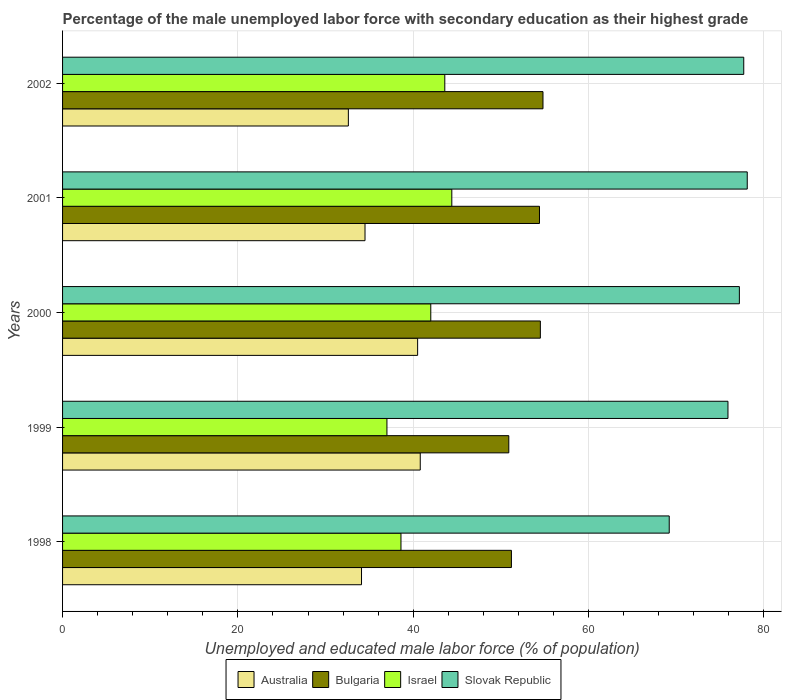How many different coloured bars are there?
Ensure brevity in your answer.  4. How many groups of bars are there?
Provide a succinct answer. 5. Are the number of bars per tick equal to the number of legend labels?
Keep it short and to the point. Yes. How many bars are there on the 2nd tick from the bottom?
Your response must be concise. 4. Across all years, what is the maximum percentage of the unemployed male labor force with secondary education in Slovak Republic?
Provide a succinct answer. 78.1. Across all years, what is the minimum percentage of the unemployed male labor force with secondary education in Slovak Republic?
Make the answer very short. 69.2. In which year was the percentage of the unemployed male labor force with secondary education in Slovak Republic maximum?
Your response must be concise. 2001. In which year was the percentage of the unemployed male labor force with secondary education in Slovak Republic minimum?
Offer a terse response. 1998. What is the total percentage of the unemployed male labor force with secondary education in Australia in the graph?
Offer a very short reply. 182.5. What is the difference between the percentage of the unemployed male labor force with secondary education in Australia in 2000 and that in 2002?
Offer a very short reply. 7.9. What is the difference between the percentage of the unemployed male labor force with secondary education in Bulgaria in 1999 and the percentage of the unemployed male labor force with secondary education in Slovak Republic in 2002?
Offer a terse response. -26.8. What is the average percentage of the unemployed male labor force with secondary education in Slovak Republic per year?
Provide a succinct answer. 75.62. In the year 2001, what is the difference between the percentage of the unemployed male labor force with secondary education in Australia and percentage of the unemployed male labor force with secondary education in Slovak Republic?
Your answer should be very brief. -43.6. In how many years, is the percentage of the unemployed male labor force with secondary education in Slovak Republic greater than 44 %?
Keep it short and to the point. 5. What is the ratio of the percentage of the unemployed male labor force with secondary education in Slovak Republic in 1999 to that in 2001?
Your response must be concise. 0.97. What is the difference between the highest and the second highest percentage of the unemployed male labor force with secondary education in Australia?
Offer a very short reply. 0.3. What is the difference between the highest and the lowest percentage of the unemployed male labor force with secondary education in Australia?
Provide a short and direct response. 8.2. In how many years, is the percentage of the unemployed male labor force with secondary education in Slovak Republic greater than the average percentage of the unemployed male labor force with secondary education in Slovak Republic taken over all years?
Ensure brevity in your answer.  4. Is it the case that in every year, the sum of the percentage of the unemployed male labor force with secondary education in Bulgaria and percentage of the unemployed male labor force with secondary education in Slovak Republic is greater than the sum of percentage of the unemployed male labor force with secondary education in Australia and percentage of the unemployed male labor force with secondary education in Israel?
Your answer should be compact. No. What does the 4th bar from the bottom in 2001 represents?
Your response must be concise. Slovak Republic. Is it the case that in every year, the sum of the percentage of the unemployed male labor force with secondary education in Australia and percentage of the unemployed male labor force with secondary education in Slovak Republic is greater than the percentage of the unemployed male labor force with secondary education in Bulgaria?
Make the answer very short. Yes. How many bars are there?
Offer a very short reply. 20. How many legend labels are there?
Offer a terse response. 4. What is the title of the graph?
Make the answer very short. Percentage of the male unemployed labor force with secondary education as their highest grade. Does "Finland" appear as one of the legend labels in the graph?
Offer a terse response. No. What is the label or title of the X-axis?
Ensure brevity in your answer.  Unemployed and educated male labor force (% of population). What is the Unemployed and educated male labor force (% of population) of Australia in 1998?
Offer a terse response. 34.1. What is the Unemployed and educated male labor force (% of population) in Bulgaria in 1998?
Give a very brief answer. 51.2. What is the Unemployed and educated male labor force (% of population) of Israel in 1998?
Provide a short and direct response. 38.6. What is the Unemployed and educated male labor force (% of population) in Slovak Republic in 1998?
Give a very brief answer. 69.2. What is the Unemployed and educated male labor force (% of population) in Australia in 1999?
Provide a succinct answer. 40.8. What is the Unemployed and educated male labor force (% of population) of Bulgaria in 1999?
Ensure brevity in your answer.  50.9. What is the Unemployed and educated male labor force (% of population) in Israel in 1999?
Offer a terse response. 37. What is the Unemployed and educated male labor force (% of population) in Slovak Republic in 1999?
Give a very brief answer. 75.9. What is the Unemployed and educated male labor force (% of population) in Australia in 2000?
Provide a short and direct response. 40.5. What is the Unemployed and educated male labor force (% of population) of Bulgaria in 2000?
Provide a succinct answer. 54.5. What is the Unemployed and educated male labor force (% of population) of Israel in 2000?
Keep it short and to the point. 42. What is the Unemployed and educated male labor force (% of population) of Slovak Republic in 2000?
Make the answer very short. 77.2. What is the Unemployed and educated male labor force (% of population) of Australia in 2001?
Provide a short and direct response. 34.5. What is the Unemployed and educated male labor force (% of population) in Bulgaria in 2001?
Your response must be concise. 54.4. What is the Unemployed and educated male labor force (% of population) of Israel in 2001?
Provide a short and direct response. 44.4. What is the Unemployed and educated male labor force (% of population) in Slovak Republic in 2001?
Your answer should be compact. 78.1. What is the Unemployed and educated male labor force (% of population) in Australia in 2002?
Your answer should be very brief. 32.6. What is the Unemployed and educated male labor force (% of population) of Bulgaria in 2002?
Your response must be concise. 54.8. What is the Unemployed and educated male labor force (% of population) of Israel in 2002?
Provide a succinct answer. 43.6. What is the Unemployed and educated male labor force (% of population) of Slovak Republic in 2002?
Ensure brevity in your answer.  77.7. Across all years, what is the maximum Unemployed and educated male labor force (% of population) in Australia?
Make the answer very short. 40.8. Across all years, what is the maximum Unemployed and educated male labor force (% of population) in Bulgaria?
Keep it short and to the point. 54.8. Across all years, what is the maximum Unemployed and educated male labor force (% of population) in Israel?
Your answer should be very brief. 44.4. Across all years, what is the maximum Unemployed and educated male labor force (% of population) of Slovak Republic?
Make the answer very short. 78.1. Across all years, what is the minimum Unemployed and educated male labor force (% of population) of Australia?
Provide a short and direct response. 32.6. Across all years, what is the minimum Unemployed and educated male labor force (% of population) in Bulgaria?
Offer a very short reply. 50.9. Across all years, what is the minimum Unemployed and educated male labor force (% of population) of Israel?
Provide a short and direct response. 37. Across all years, what is the minimum Unemployed and educated male labor force (% of population) of Slovak Republic?
Ensure brevity in your answer.  69.2. What is the total Unemployed and educated male labor force (% of population) in Australia in the graph?
Your answer should be very brief. 182.5. What is the total Unemployed and educated male labor force (% of population) in Bulgaria in the graph?
Ensure brevity in your answer.  265.8. What is the total Unemployed and educated male labor force (% of population) of Israel in the graph?
Make the answer very short. 205.6. What is the total Unemployed and educated male labor force (% of population) of Slovak Republic in the graph?
Make the answer very short. 378.1. What is the difference between the Unemployed and educated male labor force (% of population) of Israel in 1998 and that in 1999?
Provide a short and direct response. 1.6. What is the difference between the Unemployed and educated male labor force (% of population) of Israel in 1998 and that in 2000?
Your answer should be very brief. -3.4. What is the difference between the Unemployed and educated male labor force (% of population) in Australia in 1998 and that in 2001?
Your answer should be very brief. -0.4. What is the difference between the Unemployed and educated male labor force (% of population) of Israel in 1998 and that in 2001?
Give a very brief answer. -5.8. What is the difference between the Unemployed and educated male labor force (% of population) in Australia in 1998 and that in 2002?
Provide a short and direct response. 1.5. What is the difference between the Unemployed and educated male labor force (% of population) in Bulgaria in 1998 and that in 2002?
Your answer should be compact. -3.6. What is the difference between the Unemployed and educated male labor force (% of population) in Israel in 1998 and that in 2002?
Your answer should be very brief. -5. What is the difference between the Unemployed and educated male labor force (% of population) of Slovak Republic in 1998 and that in 2002?
Your response must be concise. -8.5. What is the difference between the Unemployed and educated male labor force (% of population) in Australia in 1999 and that in 2000?
Offer a very short reply. 0.3. What is the difference between the Unemployed and educated male labor force (% of population) of Bulgaria in 1999 and that in 2000?
Provide a short and direct response. -3.6. What is the difference between the Unemployed and educated male labor force (% of population) of Australia in 1999 and that in 2001?
Ensure brevity in your answer.  6.3. What is the difference between the Unemployed and educated male labor force (% of population) in Israel in 1999 and that in 2001?
Ensure brevity in your answer.  -7.4. What is the difference between the Unemployed and educated male labor force (% of population) in Slovak Republic in 1999 and that in 2001?
Your answer should be very brief. -2.2. What is the difference between the Unemployed and educated male labor force (% of population) in Bulgaria in 1999 and that in 2002?
Offer a very short reply. -3.9. What is the difference between the Unemployed and educated male labor force (% of population) in Slovak Republic in 2000 and that in 2001?
Provide a short and direct response. -0.9. What is the difference between the Unemployed and educated male labor force (% of population) of Australia in 2000 and that in 2002?
Offer a very short reply. 7.9. What is the difference between the Unemployed and educated male labor force (% of population) of Bulgaria in 2000 and that in 2002?
Offer a terse response. -0.3. What is the difference between the Unemployed and educated male labor force (% of population) of Slovak Republic in 2000 and that in 2002?
Keep it short and to the point. -0.5. What is the difference between the Unemployed and educated male labor force (% of population) of Bulgaria in 2001 and that in 2002?
Ensure brevity in your answer.  -0.4. What is the difference between the Unemployed and educated male labor force (% of population) of Israel in 2001 and that in 2002?
Ensure brevity in your answer.  0.8. What is the difference between the Unemployed and educated male labor force (% of population) in Slovak Republic in 2001 and that in 2002?
Provide a succinct answer. 0.4. What is the difference between the Unemployed and educated male labor force (% of population) in Australia in 1998 and the Unemployed and educated male labor force (% of population) in Bulgaria in 1999?
Make the answer very short. -16.8. What is the difference between the Unemployed and educated male labor force (% of population) in Australia in 1998 and the Unemployed and educated male labor force (% of population) in Slovak Republic in 1999?
Give a very brief answer. -41.8. What is the difference between the Unemployed and educated male labor force (% of population) of Bulgaria in 1998 and the Unemployed and educated male labor force (% of population) of Slovak Republic in 1999?
Provide a short and direct response. -24.7. What is the difference between the Unemployed and educated male labor force (% of population) in Israel in 1998 and the Unemployed and educated male labor force (% of population) in Slovak Republic in 1999?
Keep it short and to the point. -37.3. What is the difference between the Unemployed and educated male labor force (% of population) of Australia in 1998 and the Unemployed and educated male labor force (% of population) of Bulgaria in 2000?
Provide a succinct answer. -20.4. What is the difference between the Unemployed and educated male labor force (% of population) in Australia in 1998 and the Unemployed and educated male labor force (% of population) in Slovak Republic in 2000?
Your response must be concise. -43.1. What is the difference between the Unemployed and educated male labor force (% of population) of Bulgaria in 1998 and the Unemployed and educated male labor force (% of population) of Slovak Republic in 2000?
Your response must be concise. -26. What is the difference between the Unemployed and educated male labor force (% of population) of Israel in 1998 and the Unemployed and educated male labor force (% of population) of Slovak Republic in 2000?
Your answer should be very brief. -38.6. What is the difference between the Unemployed and educated male labor force (% of population) of Australia in 1998 and the Unemployed and educated male labor force (% of population) of Bulgaria in 2001?
Make the answer very short. -20.3. What is the difference between the Unemployed and educated male labor force (% of population) in Australia in 1998 and the Unemployed and educated male labor force (% of population) in Slovak Republic in 2001?
Provide a short and direct response. -44. What is the difference between the Unemployed and educated male labor force (% of population) in Bulgaria in 1998 and the Unemployed and educated male labor force (% of population) in Slovak Republic in 2001?
Your answer should be compact. -26.9. What is the difference between the Unemployed and educated male labor force (% of population) in Israel in 1998 and the Unemployed and educated male labor force (% of population) in Slovak Republic in 2001?
Give a very brief answer. -39.5. What is the difference between the Unemployed and educated male labor force (% of population) of Australia in 1998 and the Unemployed and educated male labor force (% of population) of Bulgaria in 2002?
Ensure brevity in your answer.  -20.7. What is the difference between the Unemployed and educated male labor force (% of population) in Australia in 1998 and the Unemployed and educated male labor force (% of population) in Israel in 2002?
Give a very brief answer. -9.5. What is the difference between the Unemployed and educated male labor force (% of population) in Australia in 1998 and the Unemployed and educated male labor force (% of population) in Slovak Republic in 2002?
Your response must be concise. -43.6. What is the difference between the Unemployed and educated male labor force (% of population) of Bulgaria in 1998 and the Unemployed and educated male labor force (% of population) of Slovak Republic in 2002?
Keep it short and to the point. -26.5. What is the difference between the Unemployed and educated male labor force (% of population) in Israel in 1998 and the Unemployed and educated male labor force (% of population) in Slovak Republic in 2002?
Provide a succinct answer. -39.1. What is the difference between the Unemployed and educated male labor force (% of population) in Australia in 1999 and the Unemployed and educated male labor force (% of population) in Bulgaria in 2000?
Give a very brief answer. -13.7. What is the difference between the Unemployed and educated male labor force (% of population) of Australia in 1999 and the Unemployed and educated male labor force (% of population) of Slovak Republic in 2000?
Provide a short and direct response. -36.4. What is the difference between the Unemployed and educated male labor force (% of population) of Bulgaria in 1999 and the Unemployed and educated male labor force (% of population) of Slovak Republic in 2000?
Ensure brevity in your answer.  -26.3. What is the difference between the Unemployed and educated male labor force (% of population) of Israel in 1999 and the Unemployed and educated male labor force (% of population) of Slovak Republic in 2000?
Offer a very short reply. -40.2. What is the difference between the Unemployed and educated male labor force (% of population) of Australia in 1999 and the Unemployed and educated male labor force (% of population) of Israel in 2001?
Ensure brevity in your answer.  -3.6. What is the difference between the Unemployed and educated male labor force (% of population) in Australia in 1999 and the Unemployed and educated male labor force (% of population) in Slovak Republic in 2001?
Give a very brief answer. -37.3. What is the difference between the Unemployed and educated male labor force (% of population) in Bulgaria in 1999 and the Unemployed and educated male labor force (% of population) in Israel in 2001?
Provide a short and direct response. 6.5. What is the difference between the Unemployed and educated male labor force (% of population) of Bulgaria in 1999 and the Unemployed and educated male labor force (% of population) of Slovak Republic in 2001?
Provide a short and direct response. -27.2. What is the difference between the Unemployed and educated male labor force (% of population) in Israel in 1999 and the Unemployed and educated male labor force (% of population) in Slovak Republic in 2001?
Provide a short and direct response. -41.1. What is the difference between the Unemployed and educated male labor force (% of population) in Australia in 1999 and the Unemployed and educated male labor force (% of population) in Slovak Republic in 2002?
Your answer should be very brief. -36.9. What is the difference between the Unemployed and educated male labor force (% of population) in Bulgaria in 1999 and the Unemployed and educated male labor force (% of population) in Israel in 2002?
Offer a terse response. 7.3. What is the difference between the Unemployed and educated male labor force (% of population) of Bulgaria in 1999 and the Unemployed and educated male labor force (% of population) of Slovak Republic in 2002?
Offer a terse response. -26.8. What is the difference between the Unemployed and educated male labor force (% of population) in Israel in 1999 and the Unemployed and educated male labor force (% of population) in Slovak Republic in 2002?
Your response must be concise. -40.7. What is the difference between the Unemployed and educated male labor force (% of population) of Australia in 2000 and the Unemployed and educated male labor force (% of population) of Israel in 2001?
Give a very brief answer. -3.9. What is the difference between the Unemployed and educated male labor force (% of population) in Australia in 2000 and the Unemployed and educated male labor force (% of population) in Slovak Republic in 2001?
Provide a succinct answer. -37.6. What is the difference between the Unemployed and educated male labor force (% of population) of Bulgaria in 2000 and the Unemployed and educated male labor force (% of population) of Israel in 2001?
Your response must be concise. 10.1. What is the difference between the Unemployed and educated male labor force (% of population) of Bulgaria in 2000 and the Unemployed and educated male labor force (% of population) of Slovak Republic in 2001?
Keep it short and to the point. -23.6. What is the difference between the Unemployed and educated male labor force (% of population) of Israel in 2000 and the Unemployed and educated male labor force (% of population) of Slovak Republic in 2001?
Offer a terse response. -36.1. What is the difference between the Unemployed and educated male labor force (% of population) of Australia in 2000 and the Unemployed and educated male labor force (% of population) of Bulgaria in 2002?
Provide a succinct answer. -14.3. What is the difference between the Unemployed and educated male labor force (% of population) of Australia in 2000 and the Unemployed and educated male labor force (% of population) of Slovak Republic in 2002?
Provide a succinct answer. -37.2. What is the difference between the Unemployed and educated male labor force (% of population) in Bulgaria in 2000 and the Unemployed and educated male labor force (% of population) in Slovak Republic in 2002?
Provide a short and direct response. -23.2. What is the difference between the Unemployed and educated male labor force (% of population) in Israel in 2000 and the Unemployed and educated male labor force (% of population) in Slovak Republic in 2002?
Keep it short and to the point. -35.7. What is the difference between the Unemployed and educated male labor force (% of population) of Australia in 2001 and the Unemployed and educated male labor force (% of population) of Bulgaria in 2002?
Make the answer very short. -20.3. What is the difference between the Unemployed and educated male labor force (% of population) in Australia in 2001 and the Unemployed and educated male labor force (% of population) in Israel in 2002?
Provide a succinct answer. -9.1. What is the difference between the Unemployed and educated male labor force (% of population) of Australia in 2001 and the Unemployed and educated male labor force (% of population) of Slovak Republic in 2002?
Provide a short and direct response. -43.2. What is the difference between the Unemployed and educated male labor force (% of population) in Bulgaria in 2001 and the Unemployed and educated male labor force (% of population) in Israel in 2002?
Keep it short and to the point. 10.8. What is the difference between the Unemployed and educated male labor force (% of population) in Bulgaria in 2001 and the Unemployed and educated male labor force (% of population) in Slovak Republic in 2002?
Ensure brevity in your answer.  -23.3. What is the difference between the Unemployed and educated male labor force (% of population) in Israel in 2001 and the Unemployed and educated male labor force (% of population) in Slovak Republic in 2002?
Ensure brevity in your answer.  -33.3. What is the average Unemployed and educated male labor force (% of population) of Australia per year?
Make the answer very short. 36.5. What is the average Unemployed and educated male labor force (% of population) of Bulgaria per year?
Provide a succinct answer. 53.16. What is the average Unemployed and educated male labor force (% of population) in Israel per year?
Offer a terse response. 41.12. What is the average Unemployed and educated male labor force (% of population) in Slovak Republic per year?
Your answer should be very brief. 75.62. In the year 1998, what is the difference between the Unemployed and educated male labor force (% of population) of Australia and Unemployed and educated male labor force (% of population) of Bulgaria?
Give a very brief answer. -17.1. In the year 1998, what is the difference between the Unemployed and educated male labor force (% of population) in Australia and Unemployed and educated male labor force (% of population) in Slovak Republic?
Make the answer very short. -35.1. In the year 1998, what is the difference between the Unemployed and educated male labor force (% of population) of Bulgaria and Unemployed and educated male labor force (% of population) of Israel?
Offer a very short reply. 12.6. In the year 1998, what is the difference between the Unemployed and educated male labor force (% of population) in Bulgaria and Unemployed and educated male labor force (% of population) in Slovak Republic?
Ensure brevity in your answer.  -18. In the year 1998, what is the difference between the Unemployed and educated male labor force (% of population) of Israel and Unemployed and educated male labor force (% of population) of Slovak Republic?
Give a very brief answer. -30.6. In the year 1999, what is the difference between the Unemployed and educated male labor force (% of population) of Australia and Unemployed and educated male labor force (% of population) of Bulgaria?
Your answer should be very brief. -10.1. In the year 1999, what is the difference between the Unemployed and educated male labor force (% of population) of Australia and Unemployed and educated male labor force (% of population) of Slovak Republic?
Your answer should be compact. -35.1. In the year 1999, what is the difference between the Unemployed and educated male labor force (% of population) of Israel and Unemployed and educated male labor force (% of population) of Slovak Republic?
Provide a succinct answer. -38.9. In the year 2000, what is the difference between the Unemployed and educated male labor force (% of population) of Australia and Unemployed and educated male labor force (% of population) of Bulgaria?
Give a very brief answer. -14. In the year 2000, what is the difference between the Unemployed and educated male labor force (% of population) of Australia and Unemployed and educated male labor force (% of population) of Slovak Republic?
Your answer should be very brief. -36.7. In the year 2000, what is the difference between the Unemployed and educated male labor force (% of population) in Bulgaria and Unemployed and educated male labor force (% of population) in Slovak Republic?
Your response must be concise. -22.7. In the year 2000, what is the difference between the Unemployed and educated male labor force (% of population) in Israel and Unemployed and educated male labor force (% of population) in Slovak Republic?
Ensure brevity in your answer.  -35.2. In the year 2001, what is the difference between the Unemployed and educated male labor force (% of population) in Australia and Unemployed and educated male labor force (% of population) in Bulgaria?
Ensure brevity in your answer.  -19.9. In the year 2001, what is the difference between the Unemployed and educated male labor force (% of population) of Australia and Unemployed and educated male labor force (% of population) of Slovak Republic?
Give a very brief answer. -43.6. In the year 2001, what is the difference between the Unemployed and educated male labor force (% of population) of Bulgaria and Unemployed and educated male labor force (% of population) of Israel?
Keep it short and to the point. 10. In the year 2001, what is the difference between the Unemployed and educated male labor force (% of population) of Bulgaria and Unemployed and educated male labor force (% of population) of Slovak Republic?
Your response must be concise. -23.7. In the year 2001, what is the difference between the Unemployed and educated male labor force (% of population) of Israel and Unemployed and educated male labor force (% of population) of Slovak Republic?
Provide a succinct answer. -33.7. In the year 2002, what is the difference between the Unemployed and educated male labor force (% of population) of Australia and Unemployed and educated male labor force (% of population) of Bulgaria?
Provide a short and direct response. -22.2. In the year 2002, what is the difference between the Unemployed and educated male labor force (% of population) in Australia and Unemployed and educated male labor force (% of population) in Israel?
Your response must be concise. -11. In the year 2002, what is the difference between the Unemployed and educated male labor force (% of population) in Australia and Unemployed and educated male labor force (% of population) in Slovak Republic?
Ensure brevity in your answer.  -45.1. In the year 2002, what is the difference between the Unemployed and educated male labor force (% of population) of Bulgaria and Unemployed and educated male labor force (% of population) of Slovak Republic?
Give a very brief answer. -22.9. In the year 2002, what is the difference between the Unemployed and educated male labor force (% of population) in Israel and Unemployed and educated male labor force (% of population) in Slovak Republic?
Your response must be concise. -34.1. What is the ratio of the Unemployed and educated male labor force (% of population) of Australia in 1998 to that in 1999?
Your response must be concise. 0.84. What is the ratio of the Unemployed and educated male labor force (% of population) of Bulgaria in 1998 to that in 1999?
Make the answer very short. 1.01. What is the ratio of the Unemployed and educated male labor force (% of population) of Israel in 1998 to that in 1999?
Keep it short and to the point. 1.04. What is the ratio of the Unemployed and educated male labor force (% of population) in Slovak Republic in 1998 to that in 1999?
Your answer should be compact. 0.91. What is the ratio of the Unemployed and educated male labor force (% of population) of Australia in 1998 to that in 2000?
Provide a short and direct response. 0.84. What is the ratio of the Unemployed and educated male labor force (% of population) of Bulgaria in 1998 to that in 2000?
Ensure brevity in your answer.  0.94. What is the ratio of the Unemployed and educated male labor force (% of population) of Israel in 1998 to that in 2000?
Offer a very short reply. 0.92. What is the ratio of the Unemployed and educated male labor force (% of population) in Slovak Republic in 1998 to that in 2000?
Your response must be concise. 0.9. What is the ratio of the Unemployed and educated male labor force (% of population) of Australia in 1998 to that in 2001?
Your answer should be compact. 0.99. What is the ratio of the Unemployed and educated male labor force (% of population) in Israel in 1998 to that in 2001?
Make the answer very short. 0.87. What is the ratio of the Unemployed and educated male labor force (% of population) of Slovak Republic in 1998 to that in 2001?
Your answer should be very brief. 0.89. What is the ratio of the Unemployed and educated male labor force (% of population) in Australia in 1998 to that in 2002?
Offer a very short reply. 1.05. What is the ratio of the Unemployed and educated male labor force (% of population) of Bulgaria in 1998 to that in 2002?
Offer a very short reply. 0.93. What is the ratio of the Unemployed and educated male labor force (% of population) in Israel in 1998 to that in 2002?
Your answer should be compact. 0.89. What is the ratio of the Unemployed and educated male labor force (% of population) of Slovak Republic in 1998 to that in 2002?
Your answer should be very brief. 0.89. What is the ratio of the Unemployed and educated male labor force (% of population) of Australia in 1999 to that in 2000?
Keep it short and to the point. 1.01. What is the ratio of the Unemployed and educated male labor force (% of population) in Bulgaria in 1999 to that in 2000?
Provide a short and direct response. 0.93. What is the ratio of the Unemployed and educated male labor force (% of population) in Israel in 1999 to that in 2000?
Keep it short and to the point. 0.88. What is the ratio of the Unemployed and educated male labor force (% of population) in Slovak Republic in 1999 to that in 2000?
Your response must be concise. 0.98. What is the ratio of the Unemployed and educated male labor force (% of population) in Australia in 1999 to that in 2001?
Your answer should be compact. 1.18. What is the ratio of the Unemployed and educated male labor force (% of population) in Bulgaria in 1999 to that in 2001?
Your answer should be very brief. 0.94. What is the ratio of the Unemployed and educated male labor force (% of population) in Israel in 1999 to that in 2001?
Offer a terse response. 0.83. What is the ratio of the Unemployed and educated male labor force (% of population) in Slovak Republic in 1999 to that in 2001?
Make the answer very short. 0.97. What is the ratio of the Unemployed and educated male labor force (% of population) in Australia in 1999 to that in 2002?
Offer a terse response. 1.25. What is the ratio of the Unemployed and educated male labor force (% of population) of Bulgaria in 1999 to that in 2002?
Provide a short and direct response. 0.93. What is the ratio of the Unemployed and educated male labor force (% of population) in Israel in 1999 to that in 2002?
Your answer should be very brief. 0.85. What is the ratio of the Unemployed and educated male labor force (% of population) of Slovak Republic in 1999 to that in 2002?
Make the answer very short. 0.98. What is the ratio of the Unemployed and educated male labor force (% of population) in Australia in 2000 to that in 2001?
Your answer should be very brief. 1.17. What is the ratio of the Unemployed and educated male labor force (% of population) in Israel in 2000 to that in 2001?
Provide a succinct answer. 0.95. What is the ratio of the Unemployed and educated male labor force (% of population) in Australia in 2000 to that in 2002?
Make the answer very short. 1.24. What is the ratio of the Unemployed and educated male labor force (% of population) in Bulgaria in 2000 to that in 2002?
Provide a short and direct response. 0.99. What is the ratio of the Unemployed and educated male labor force (% of population) of Israel in 2000 to that in 2002?
Give a very brief answer. 0.96. What is the ratio of the Unemployed and educated male labor force (% of population) in Australia in 2001 to that in 2002?
Provide a succinct answer. 1.06. What is the ratio of the Unemployed and educated male labor force (% of population) in Israel in 2001 to that in 2002?
Your response must be concise. 1.02. What is the ratio of the Unemployed and educated male labor force (% of population) in Slovak Republic in 2001 to that in 2002?
Give a very brief answer. 1.01. What is the difference between the highest and the lowest Unemployed and educated male labor force (% of population) in Bulgaria?
Make the answer very short. 3.9. 